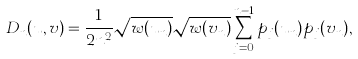<formula> <loc_0><loc_0><loc_500><loc_500>D _ { n } ( u , v ) = \frac { 1 } { 2 n ^ { 2 } } \sqrt { w ( u _ { n } ) } \sqrt { w ( v _ { n } ) } \sum _ { j = 0 } ^ { n - 1 } p _ { j } ( u _ { n } ) p _ { j } ( v _ { n } ) ,</formula> 